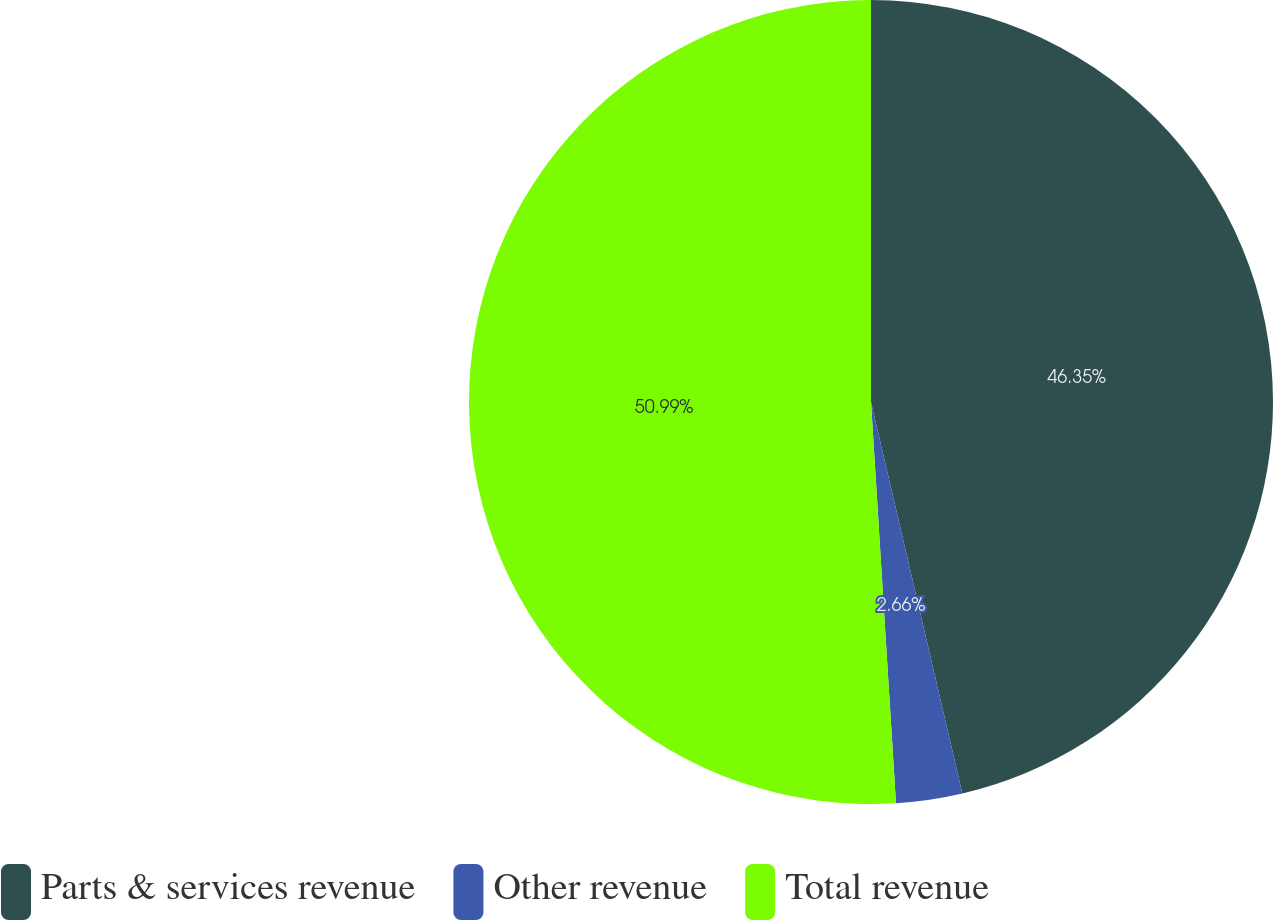Convert chart. <chart><loc_0><loc_0><loc_500><loc_500><pie_chart><fcel>Parts & services revenue<fcel>Other revenue<fcel>Total revenue<nl><fcel>46.35%<fcel>2.66%<fcel>50.99%<nl></chart> 